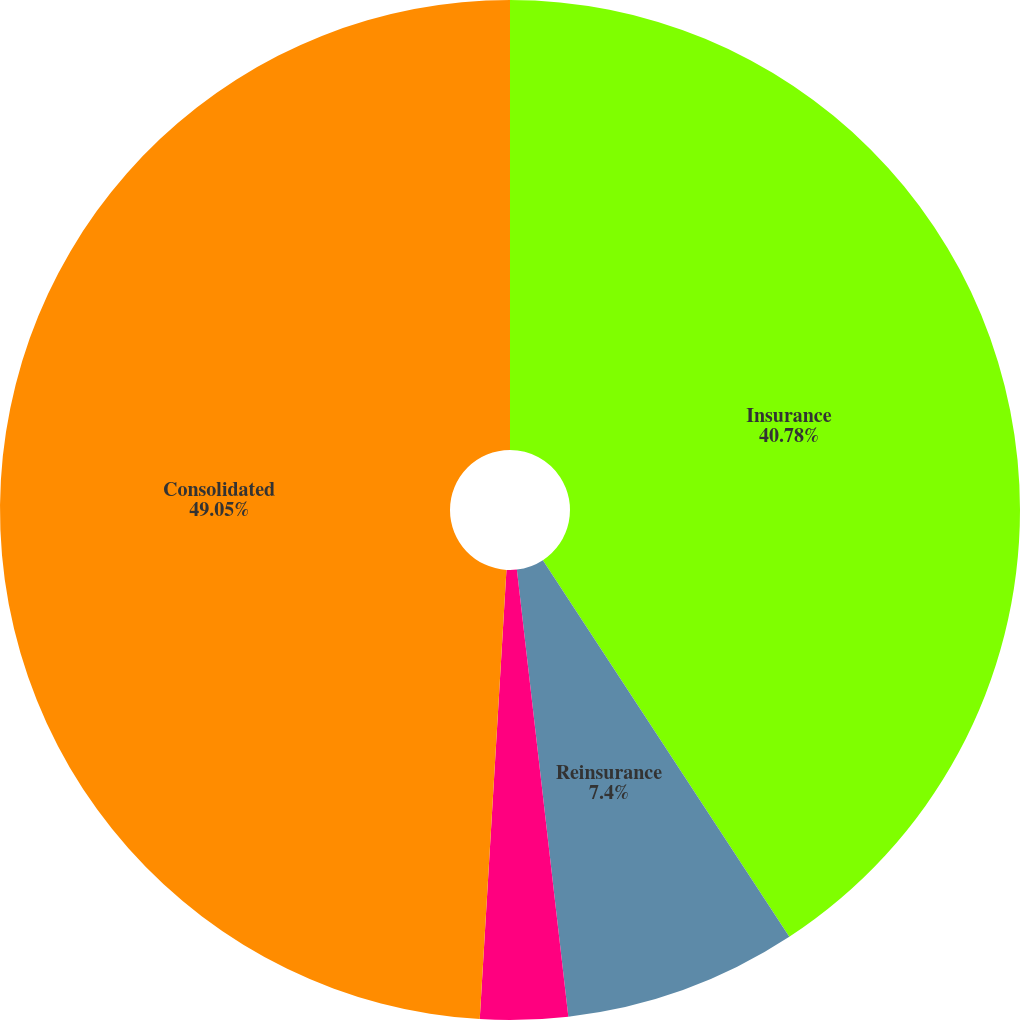Convert chart. <chart><loc_0><loc_0><loc_500><loc_500><pie_chart><fcel>Insurance<fcel>Reinsurance<fcel>Corporate other and<fcel>Consolidated<nl><fcel>40.78%<fcel>7.4%<fcel>2.77%<fcel>49.06%<nl></chart> 